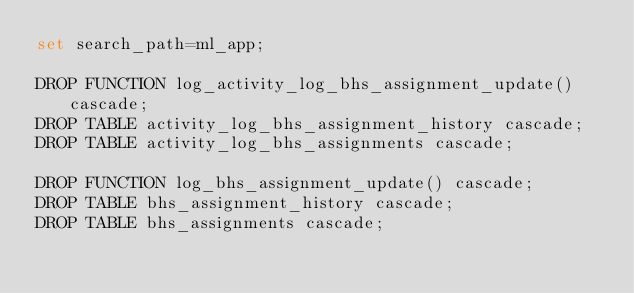<code> <loc_0><loc_0><loc_500><loc_500><_SQL_>set search_path=ml_app;

DROP FUNCTION log_activity_log_bhs_assignment_update() cascade;
DROP TABLE activity_log_bhs_assignment_history cascade;
DROP TABLE activity_log_bhs_assignments cascade;

DROP FUNCTION log_bhs_assignment_update() cascade;
DROP TABLE bhs_assignment_history cascade;
DROP TABLE bhs_assignments cascade;
</code> 